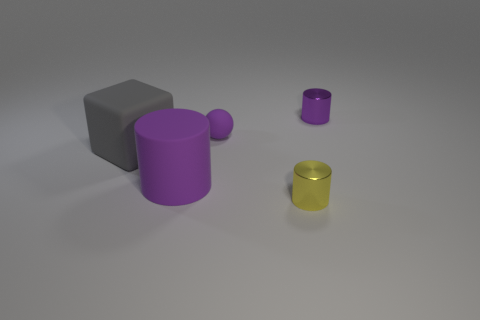What is the material of the purple ball that is the same size as the yellow metal cylinder?
Offer a terse response. Rubber. There is a large gray matte thing; are there any large gray things in front of it?
Offer a very short reply. No. Are there the same number of rubber spheres that are to the left of the tiny yellow cylinder and purple shiny things?
Make the answer very short. Yes. What shape is the other purple object that is the same size as the purple metal object?
Offer a terse response. Sphere. What material is the large gray thing?
Give a very brief answer. Rubber. The rubber object that is behind the purple rubber cylinder and on the right side of the rubber block is what color?
Offer a terse response. Purple. Are there an equal number of rubber objects on the right side of the yellow metal cylinder and purple rubber objects that are to the right of the cube?
Ensure brevity in your answer.  No. There is a large block that is made of the same material as the tiny ball; what color is it?
Offer a very short reply. Gray. There is a rubber sphere; does it have the same color as the tiny cylinder that is behind the yellow shiny object?
Make the answer very short. Yes. Is there a gray cube right of the metal cylinder in front of the tiny shiny thing behind the big rubber cube?
Your response must be concise. No. 